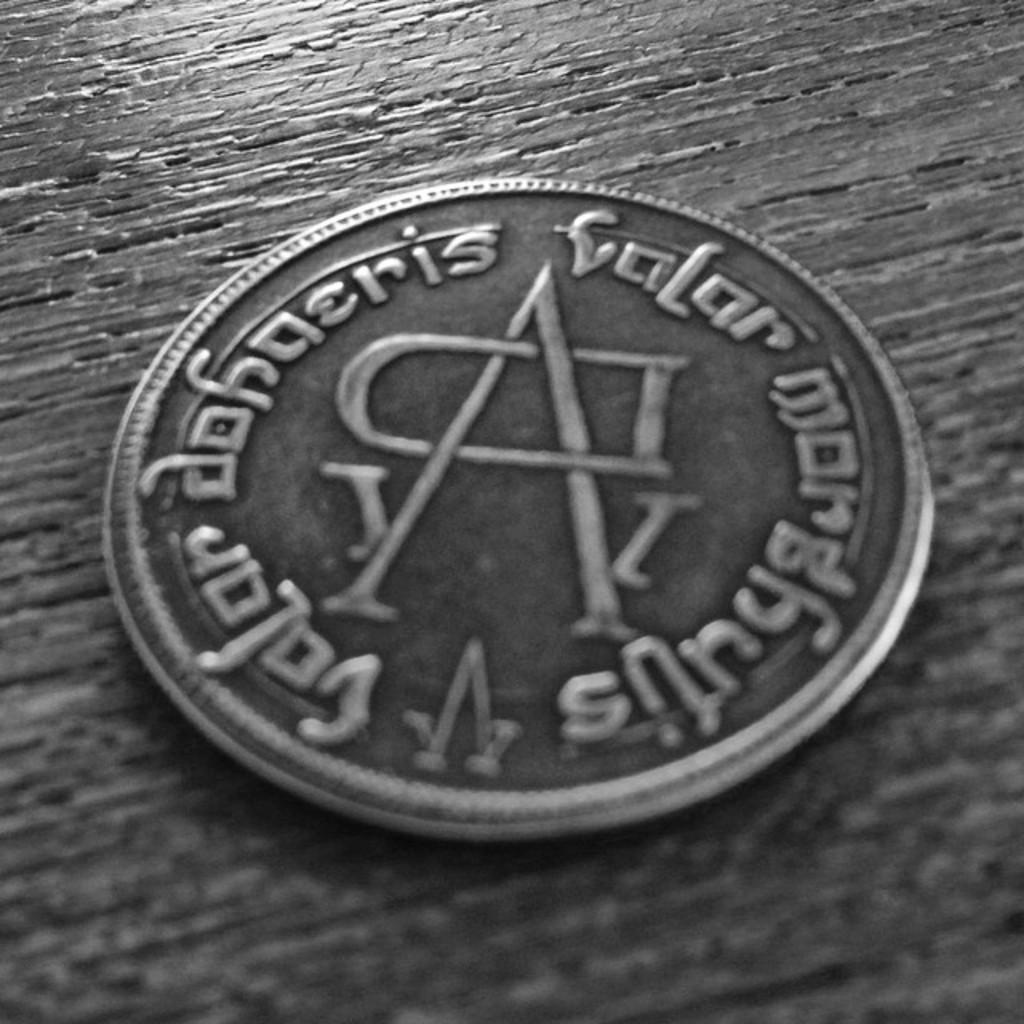What is the main subject of the image? The main subject of the image is a coin. What can be seen on the coin? The coin has texts on it. Where is the coin located in the image? The coin is placed on a surface. What is the color of the background in the image? The background of the image is gray in color. What type of cord is connected to the pump in the image? There is no pump or cord present in the image; it only features a coin with texts on it. 